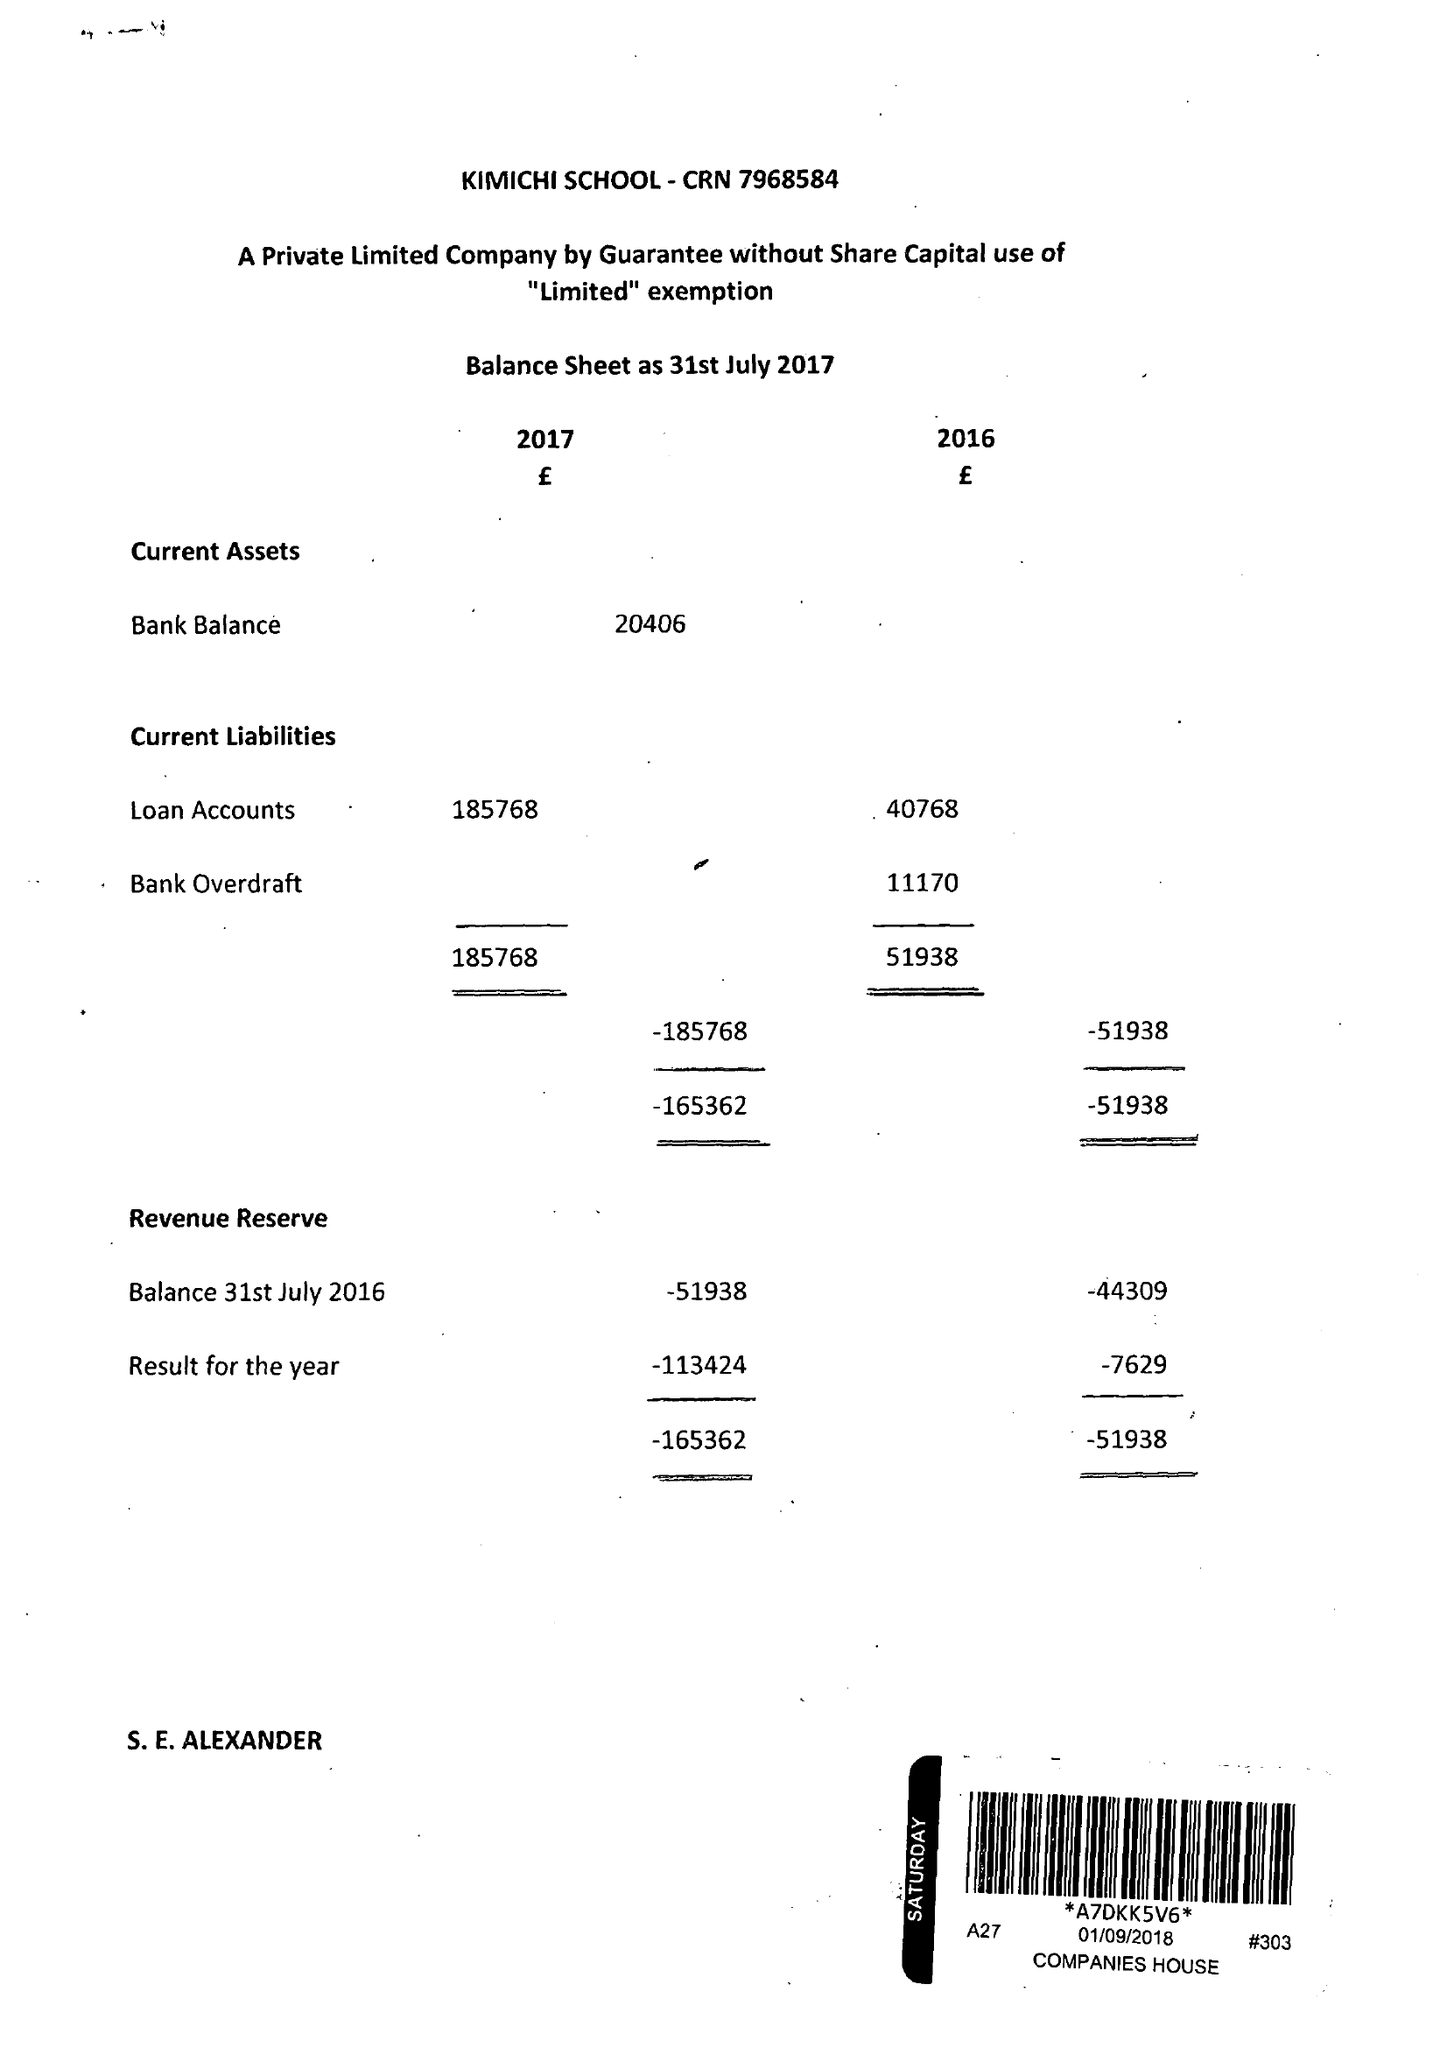What is the value for the spending_annually_in_british_pounds?
Answer the question using a single word or phrase. 201535.00 